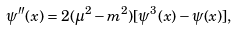Convert formula to latex. <formula><loc_0><loc_0><loc_500><loc_500>\psi ^ { \prime \prime } ( x ) = 2 ( \mu ^ { 2 } - m ^ { 2 } ) [ \psi ^ { 3 } ( x ) - \psi ( x ) ] ,</formula> 